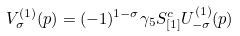Convert formula to latex. <formula><loc_0><loc_0><loc_500><loc_500>V _ { \sigma } ^ { ( 1 ) } ( p ) = ( - 1 ) ^ { 1 - \sigma } \gamma _ { 5 } S _ { [ 1 ] } ^ { c } U _ { - \sigma } ^ { ( 1 ) } ( p )</formula> 